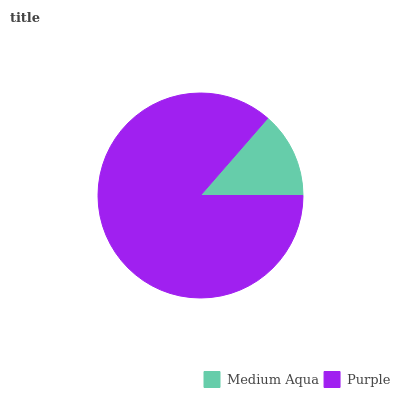Is Medium Aqua the minimum?
Answer yes or no. Yes. Is Purple the maximum?
Answer yes or no. Yes. Is Purple the minimum?
Answer yes or no. No. Is Purple greater than Medium Aqua?
Answer yes or no. Yes. Is Medium Aqua less than Purple?
Answer yes or no. Yes. Is Medium Aqua greater than Purple?
Answer yes or no. No. Is Purple less than Medium Aqua?
Answer yes or no. No. Is Purple the high median?
Answer yes or no. Yes. Is Medium Aqua the low median?
Answer yes or no. Yes. Is Medium Aqua the high median?
Answer yes or no. No. Is Purple the low median?
Answer yes or no. No. 